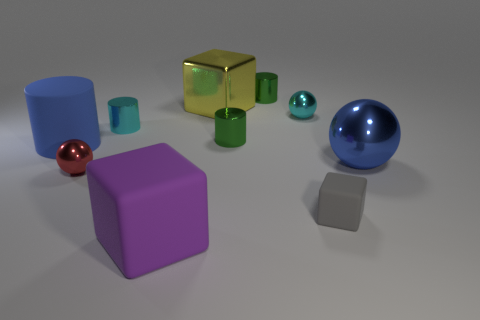Subtract all tiny cyan cylinders. How many cylinders are left? 3 Subtract all green balls. How many green cylinders are left? 2 Subtract all balls. How many objects are left? 7 Subtract all red spheres. How many spheres are left? 2 Subtract 0 gray spheres. How many objects are left? 10 Subtract all gray balls. Subtract all gray cubes. How many balls are left? 3 Subtract all big metal objects. Subtract all blue matte blocks. How many objects are left? 8 Add 7 tiny matte things. How many tiny matte things are left? 8 Add 7 gray cubes. How many gray cubes exist? 8 